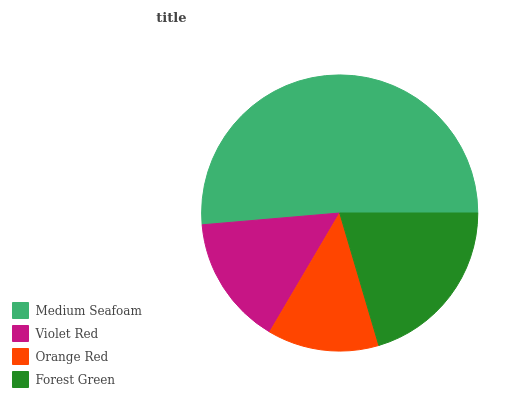Is Orange Red the minimum?
Answer yes or no. Yes. Is Medium Seafoam the maximum?
Answer yes or no. Yes. Is Violet Red the minimum?
Answer yes or no. No. Is Violet Red the maximum?
Answer yes or no. No. Is Medium Seafoam greater than Violet Red?
Answer yes or no. Yes. Is Violet Red less than Medium Seafoam?
Answer yes or no. Yes. Is Violet Red greater than Medium Seafoam?
Answer yes or no. No. Is Medium Seafoam less than Violet Red?
Answer yes or no. No. Is Forest Green the high median?
Answer yes or no. Yes. Is Violet Red the low median?
Answer yes or no. Yes. Is Orange Red the high median?
Answer yes or no. No. Is Forest Green the low median?
Answer yes or no. No. 